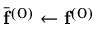<formula> <loc_0><loc_0><loc_500><loc_500>\bar { f } ^ { ( 0 ) } \leftarrow f ^ { ( 0 ) }</formula> 